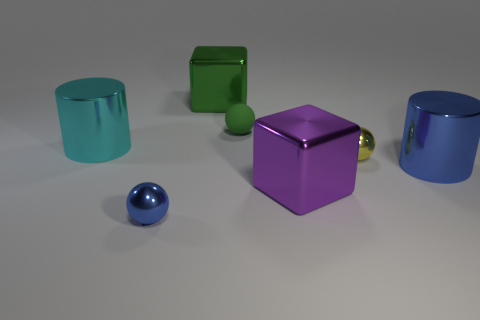Are there any tiny yellow metal objects of the same shape as the cyan shiny thing?
Offer a terse response. No. There is a cyan shiny object; is its shape the same as the small thing behind the large cyan shiny cylinder?
Give a very brief answer. No. There is a metal object that is both to the right of the large purple thing and in front of the yellow metal object; how big is it?
Offer a terse response. Large. How many tiny cyan shiny cylinders are there?
Provide a short and direct response. 0. What is the material of the cyan thing that is the same size as the purple shiny block?
Provide a short and direct response. Metal. Are there any cyan cylinders of the same size as the yellow metallic ball?
Ensure brevity in your answer.  No. There is a small metallic ball that is behind the tiny blue sphere; is its color the same as the sphere that is behind the large cyan metal thing?
Your answer should be very brief. No. What number of rubber things are big brown cylinders or big things?
Keep it short and to the point. 0. What number of cubes are left of the large block behind the green sphere that is on the left side of the big purple shiny object?
Provide a succinct answer. 0. The cyan thing that is made of the same material as the tiny yellow thing is what size?
Keep it short and to the point. Large. 